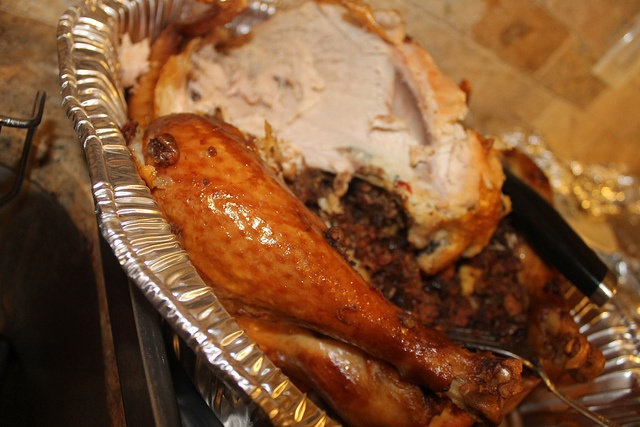Describe the objects in this image and their specific colors. I can see dining table in brown, olive, and tan tones, knife in brown, black, maroon, and olive tones, and fork in brown, maroon, and black tones in this image. 